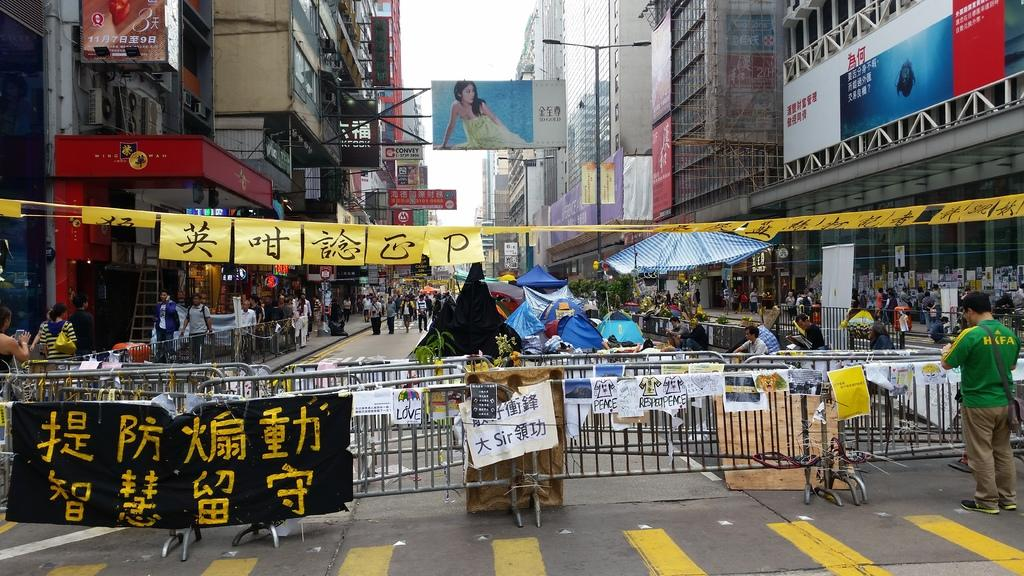<image>
Describe the image concisely. A street scene where there is a sign on a barricade that says Respect Peace. 